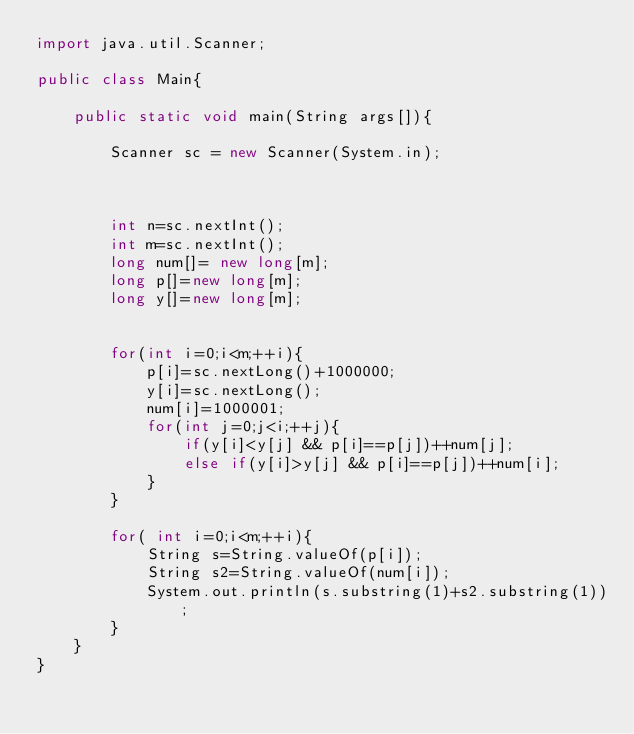<code> <loc_0><loc_0><loc_500><loc_500><_Java_>import java.util.Scanner;

public class Main{

	public static void main(String args[]){

		Scanner sc = new Scanner(System.in);



		int n=sc.nextInt();
		int m=sc.nextInt();
		long num[]= new long[m];
		long p[]=new long[m];
		long y[]=new long[m];


		for(int i=0;i<m;++i){
			p[i]=sc.nextLong()+1000000;
			y[i]=sc.nextLong();
			num[i]=1000001;
			for(int j=0;j<i;++j){
				if(y[i]<y[j] && p[i]==p[j])++num[j];
				else if(y[i]>y[j] && p[i]==p[j])++num[i];
			}
		}

		for( int i=0;i<m;++i){
			String s=String.valueOf(p[i]);
			String s2=String.valueOf(num[i]);
			System.out.println(s.substring(1)+s2.substring(1));
		}
	}
}</code> 